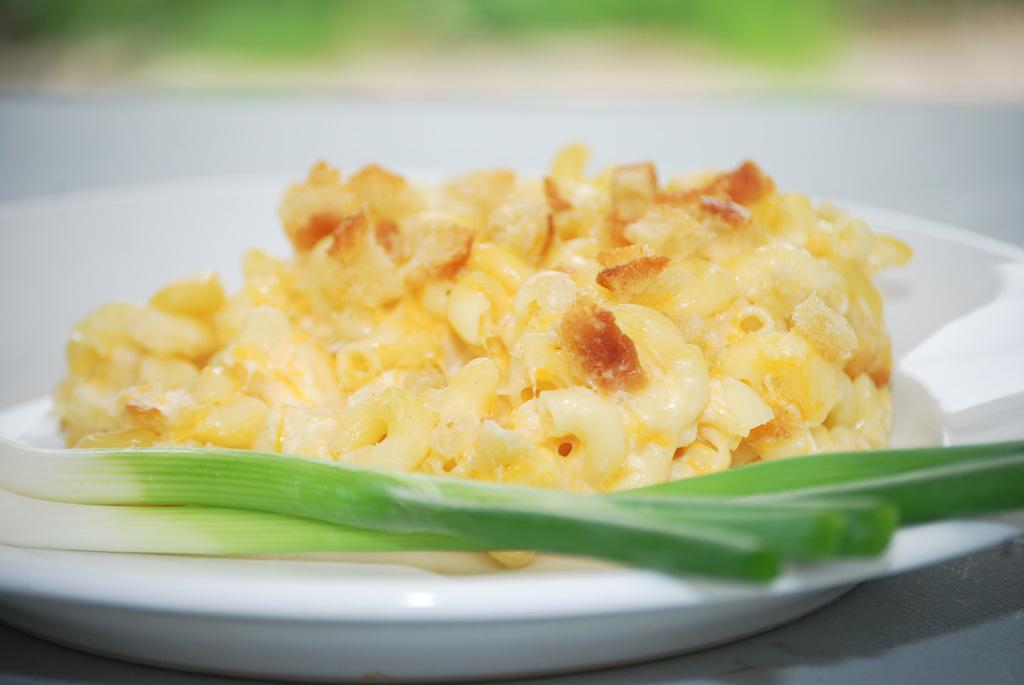What color is the food in the image? The food in the image is yellow-colored. What other color can be seen in the image besides yellow? There is a green-colored thing in the image. What is the color of the plate on which the food and the green thing are placed? The plate is white-colored. How would you describe the overall clarity of the image? The image is slightly blurry in the background. What time of day does the image depict, specifically in the afternoon? The image does not depict a specific time of day, and there is no indication of the afternoon in the image. 